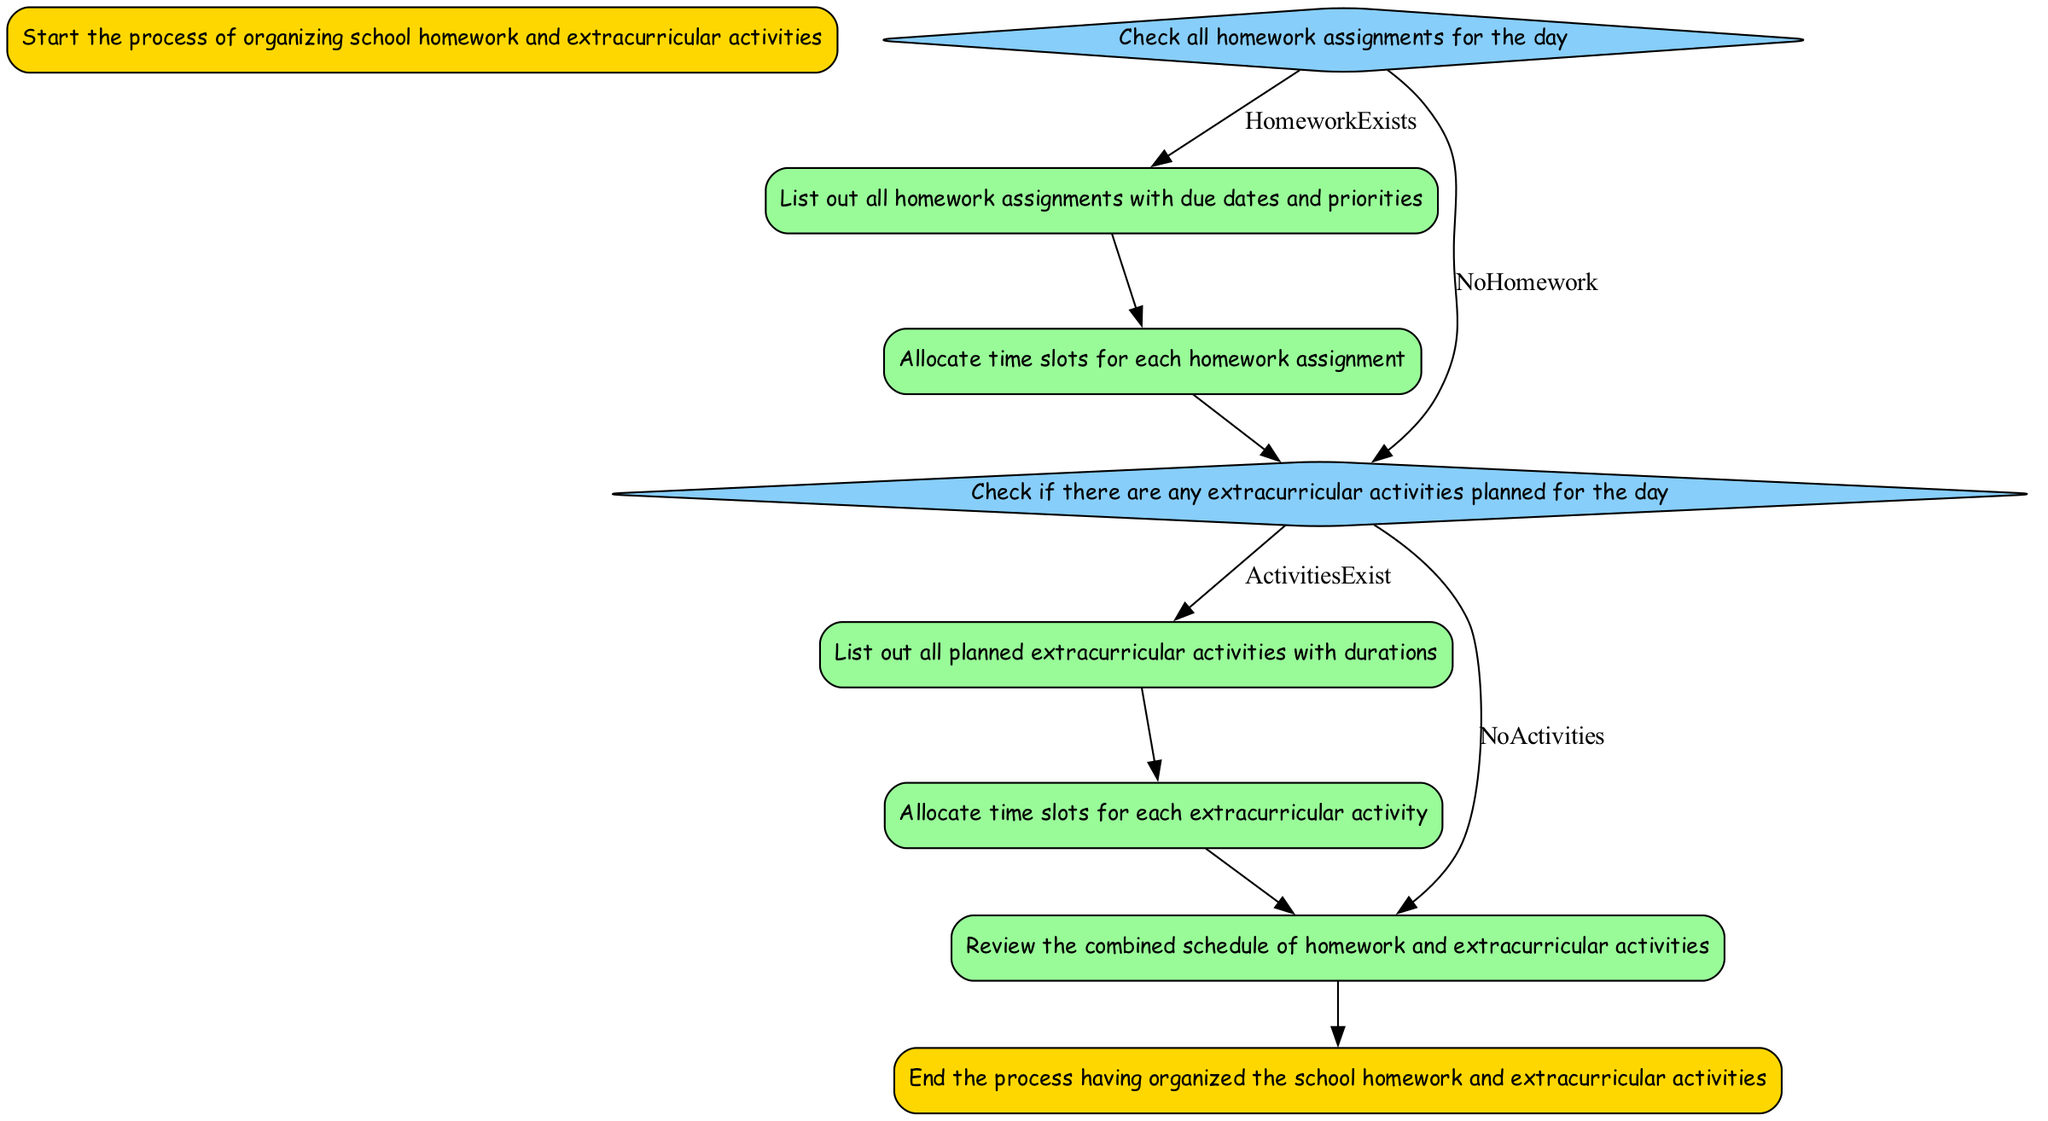What is the first step in the process? The first step in the diagram is labeled "Start," which initiates the process of organizing school homework and extracurricular activities.
Answer: Start How many decision points are present in the diagram? There are two decision points in the diagram: "CheckHomeworkAssignments" and "CheckExtracurricularActivities."
Answer: 2 What happens after listing out homework assignments? After listing out all homework assignments, the next step is "AllocateHomeworkTime" to allocate time slots for each assignment.
Answer: AllocateHomeworkTime If there are no homework assignments, what is the next step? If no homework assignments are present, the diagram indicates that the next step is "CheckExtracurricularActivities."
Answer: CheckExtracurricularActivities What color is used for decision nodes? Decision nodes in the diagram are filled with the color Light Sky Blue, as defined for their specific style.
Answer: Light Sky Blue What is the last step of the organizing process? The last step in the process is labeled "End," marking the completion of organizing school homework and extracurricular activities.
Answer: End What comes after listing extracurricular activities? Following the listing of extracurricular activities, the next step is "AllocateActivityTime," where time slots for each activity are allocated.
Answer: AllocateActivityTime What describes the "ReviewSchedule" step? The "ReviewSchedule" step involves reviewing the combined schedule of both homework and extracurricular activities to ensure everything fits well.
Answer: Review combined schedule What type of node is "CheckHomeworkAssignments"? The "CheckHomeworkAssignments" node is a decision type, indicated by its diamond shape in the diagram.
Answer: Decision 